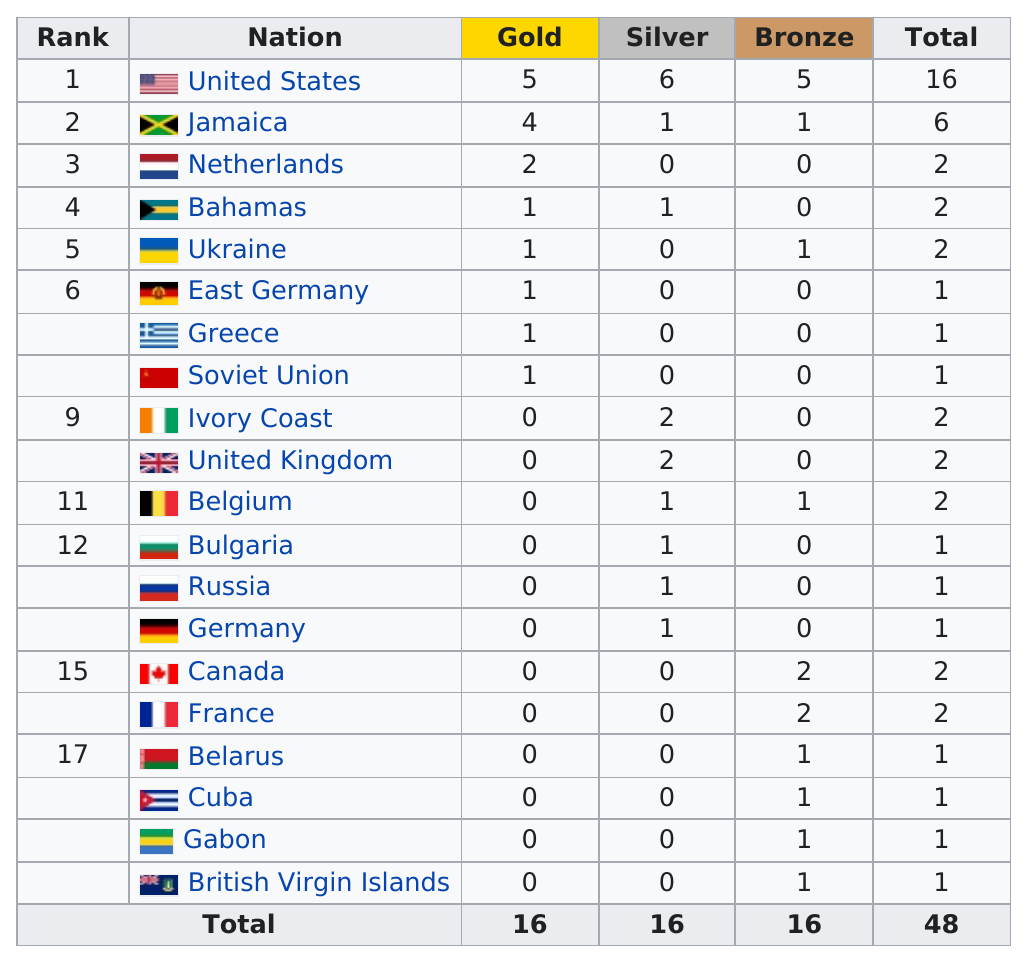Indicate a few pertinent items in this graphic. According to the information available, the top 5 nations have won an average of 2.6 gold medals each. The United States is the country that has won the most gold medals in history. The United States has won at least three silver medals. The United States received more medals than Canada, and two countries received more medals than the United States. Out of the 10 nations that received a medal, only one received one medal. 